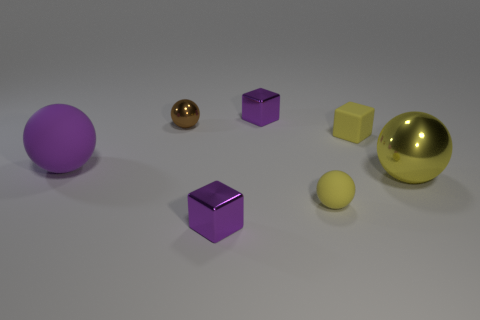Add 1 rubber cubes. How many objects exist? 8 Subtract all spheres. How many objects are left? 3 Add 5 tiny brown spheres. How many tiny brown spheres are left? 6 Add 6 shiny blocks. How many shiny blocks exist? 8 Subtract 1 purple blocks. How many objects are left? 6 Subtract all big shiny objects. Subtract all rubber spheres. How many objects are left? 4 